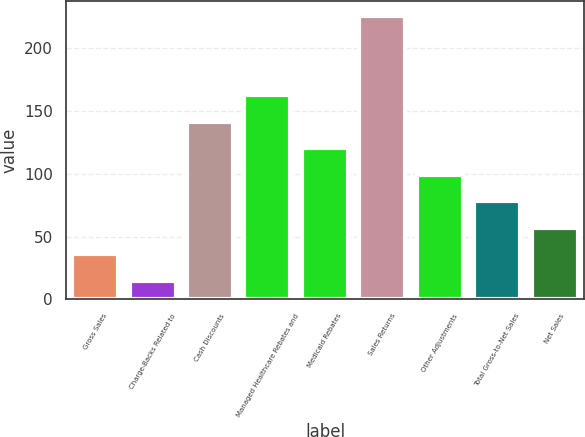Convert chart to OTSL. <chart><loc_0><loc_0><loc_500><loc_500><bar_chart><fcel>Gross Sales<fcel>Charge-Backs Related to<fcel>Cash Discounts<fcel>Managed Healthcare Rebates and<fcel>Medicaid Rebates<fcel>Sales Returns<fcel>Other Adjustments<fcel>Total Gross-to-Net Sales<fcel>Net Sales<nl><fcel>36.1<fcel>15<fcel>141.6<fcel>162.7<fcel>120.5<fcel>226<fcel>99.4<fcel>78.3<fcel>57.2<nl></chart> 